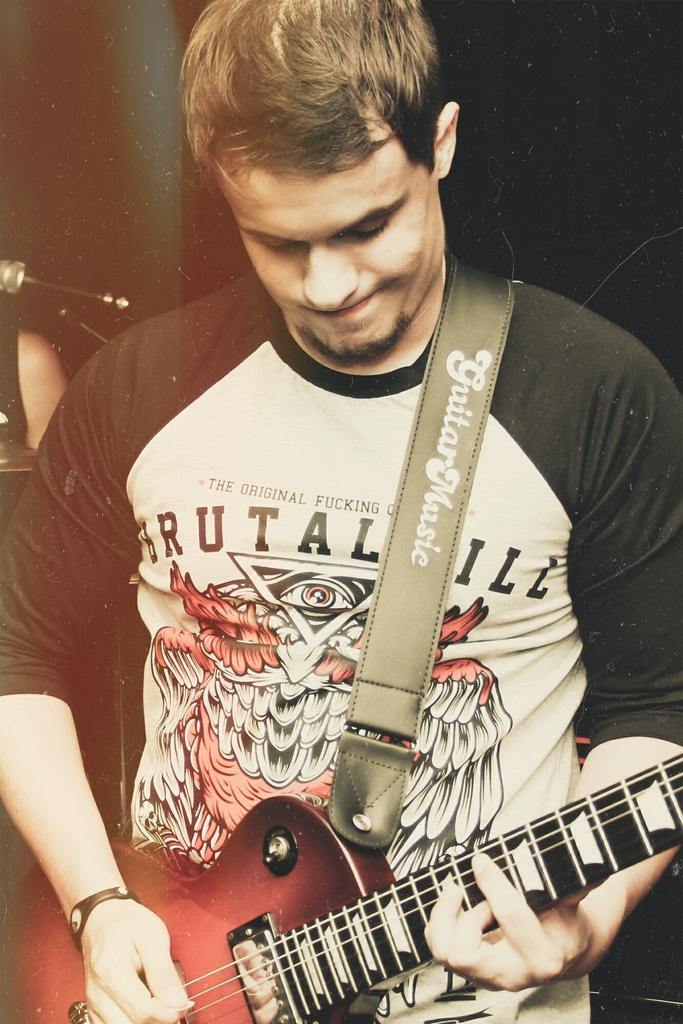What is the main subject of the image? The main subject of the image is a man. What is the man holding in his hand? The man is holding a guitar in his hand. What type of coal is the man using to fuel the fire in the image? There is no coal or fire present in the image; the man is holding a guitar. 